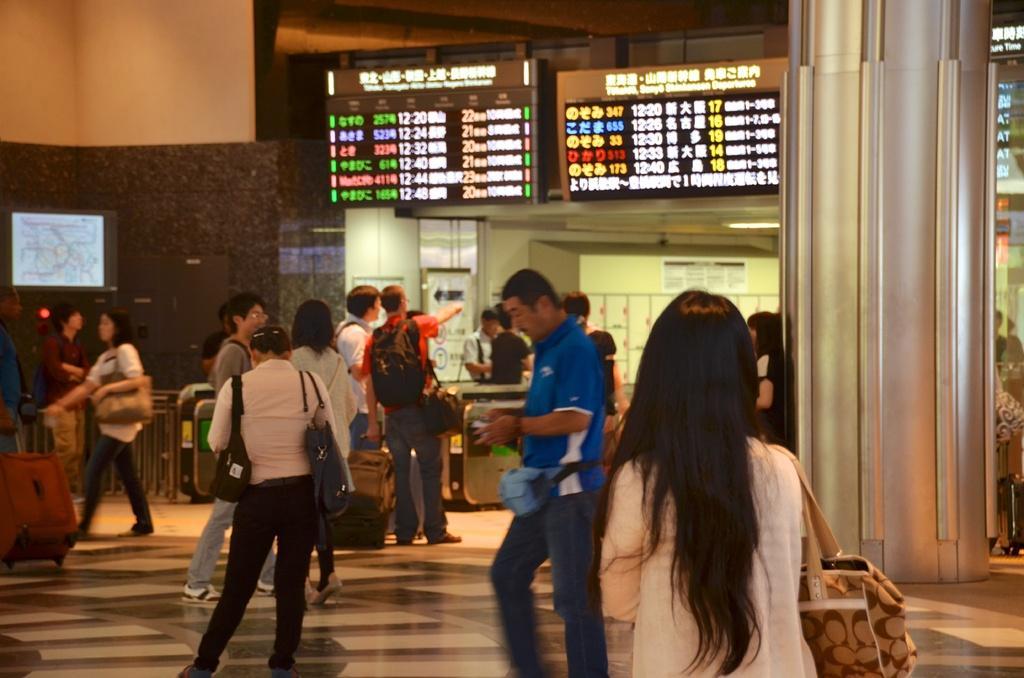How would you summarize this image in a sentence or two? In this image I can see the group of people and few people are wearing bags and few are holding something. I can see few screens, fencing, pillar and the wall. 